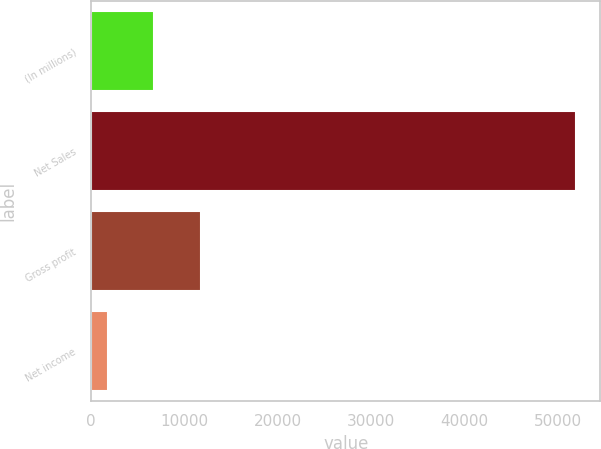Convert chart to OTSL. <chart><loc_0><loc_0><loc_500><loc_500><bar_chart><fcel>(In millions)<fcel>Net Sales<fcel>Gross profit<fcel>Net income<nl><fcel>6782.5<fcel>51967<fcel>11803<fcel>1762<nl></chart> 